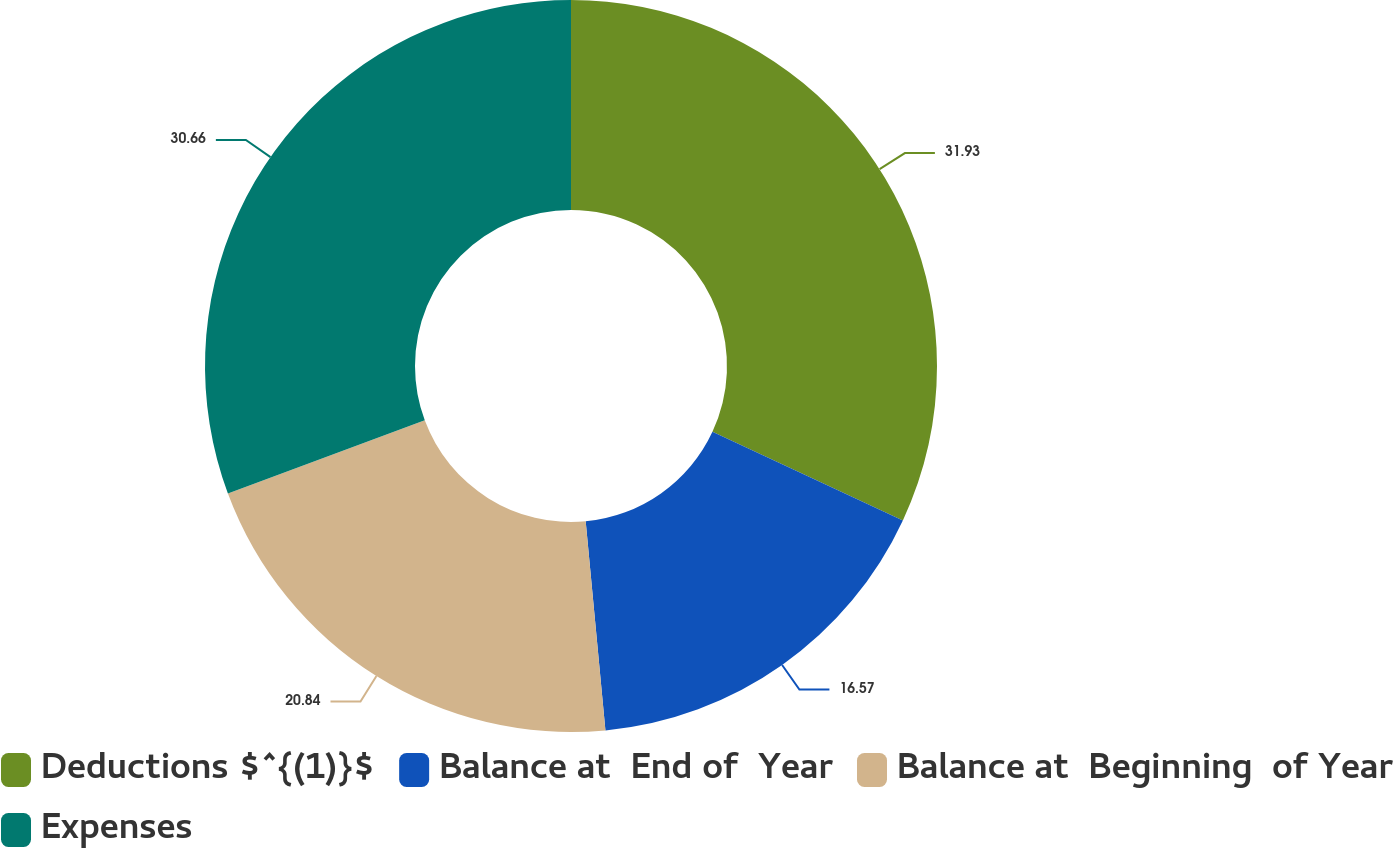Convert chart. <chart><loc_0><loc_0><loc_500><loc_500><pie_chart><fcel>Deductions $^{(1)}$<fcel>Balance at  End of  Year<fcel>Balance at  Beginning  of Year<fcel>Expenses<nl><fcel>31.93%<fcel>16.57%<fcel>20.84%<fcel>30.66%<nl></chart> 